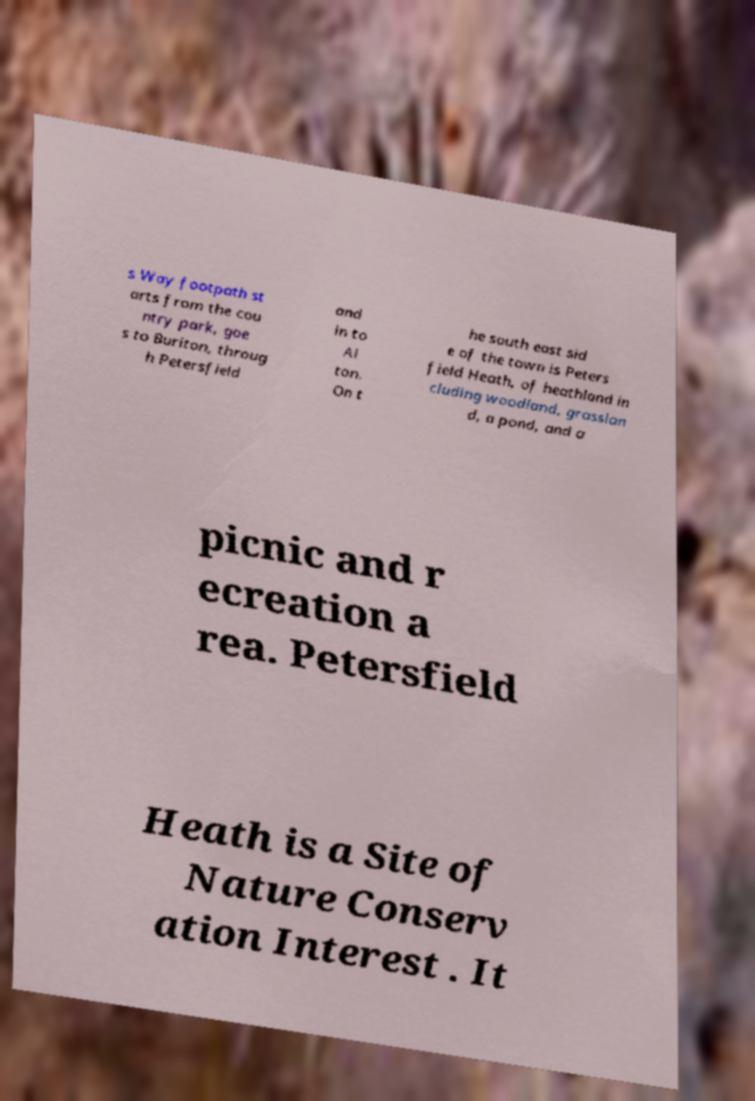Could you extract and type out the text from this image? s Way footpath st arts from the cou ntry park, goe s to Buriton, throug h Petersfield and in to Al ton. On t he south east sid e of the town is Peters field Heath, of heathland in cluding woodland, grasslan d, a pond, and a picnic and r ecreation a rea. Petersfield Heath is a Site of Nature Conserv ation Interest . It 